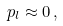<formula> <loc_0><loc_0><loc_500><loc_500>p _ { l } \approx 0 \, ,</formula> 